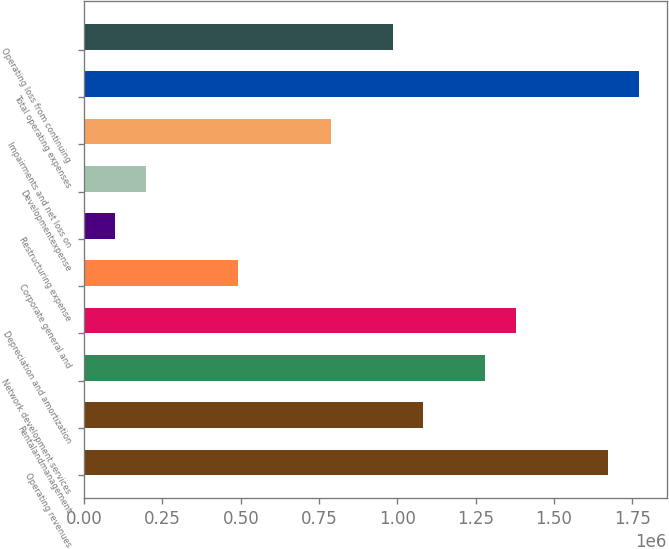Convert chart. <chart><loc_0><loc_0><loc_500><loc_500><bar_chart><fcel>Operating revenues<fcel>Rentalandmanagement<fcel>Network development services<fcel>Depreciation and amortization<fcel>Corporate general and<fcel>Restructuring expense<fcel>Developmentexpense<fcel>Impairments and net loss on<fcel>Total operating expenses<fcel>Operating loss from continuing<nl><fcel>1.67364e+06<fcel>1.08306e+06<fcel>1.27992e+06<fcel>1.37835e+06<fcel>492472<fcel>98748.8<fcel>197180<fcel>787764<fcel>1.77207e+06<fcel>984626<nl></chart> 